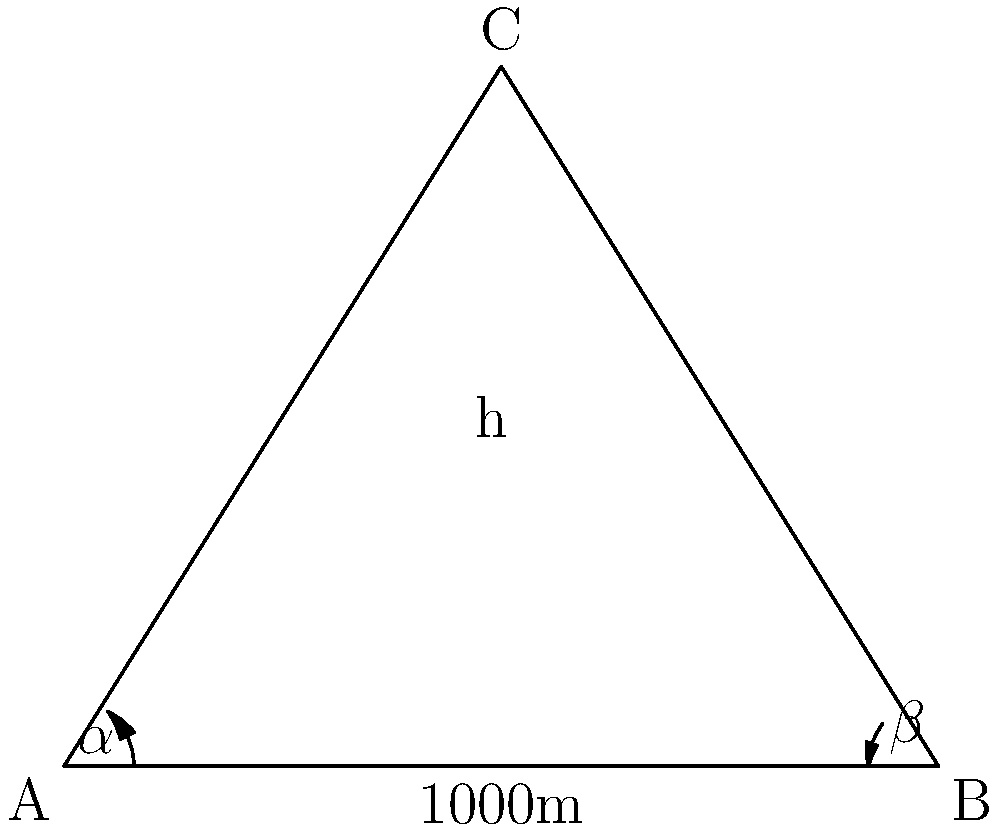As a freelance photographer, you're on assignment to capture a unique mountain peak. To determine the best lens and positioning for your shot, you need to calculate the height of the peak. You measure the angle of elevation from two points (A and B) that are 1000m apart on level ground. The angle of elevation from point A is $\alpha = 51.3°$, and from point B is $\beta = 36.9°$. What is the height of the mountain peak to the nearest meter? Let's solve this step-by-step using trigonometry:

1) First, we need to set up the problem. We have a triangle ABC where:
   - AB is the distance between the two measurement points (1000m)
   - C is the mountain peak
   - ∠CAB = $\alpha = 51.3°$
   - ∠CBA = $\beta = 36.9°$

2) We can use the tangent function to set up two equations:
   $$\tan(\alpha) = \frac{h}{x}$$
   $$\tan(\beta) = \frac{h}{1000-x}$$

   Where h is the height of the mountain and x is the distance from point A to the point directly below the peak.

3) We can equate these:
   $$\frac{h}{\tan(\alpha)} = x$$
   $$\frac{h}{\tan(\beta)} = 1000-x$$

4) Adding these equations:
   $$\frac{h}{\tan(\alpha)} + \frac{h}{\tan(\beta)} = 1000$$

5) Factor out h:
   $$h(\frac{1}{\tan(\alpha)} + \frac{1}{\tan(\beta)}) = 1000$$

6) Solve for h:
   $$h = \frac{1000}{\frac{1}{\tan(\alpha)} + \frac{1}{\tan(\beta)}}$$

7) Now let's plug in our values:
   $$h = \frac{1000}{\frac{1}{\tan(51.3°)} + \frac{1}{\tan(36.9°)}}$$

8) Calculate:
   $$h ≈ 632.46$$

9) Rounding to the nearest meter:
   $$h ≈ 632m$$
Answer: 632m 